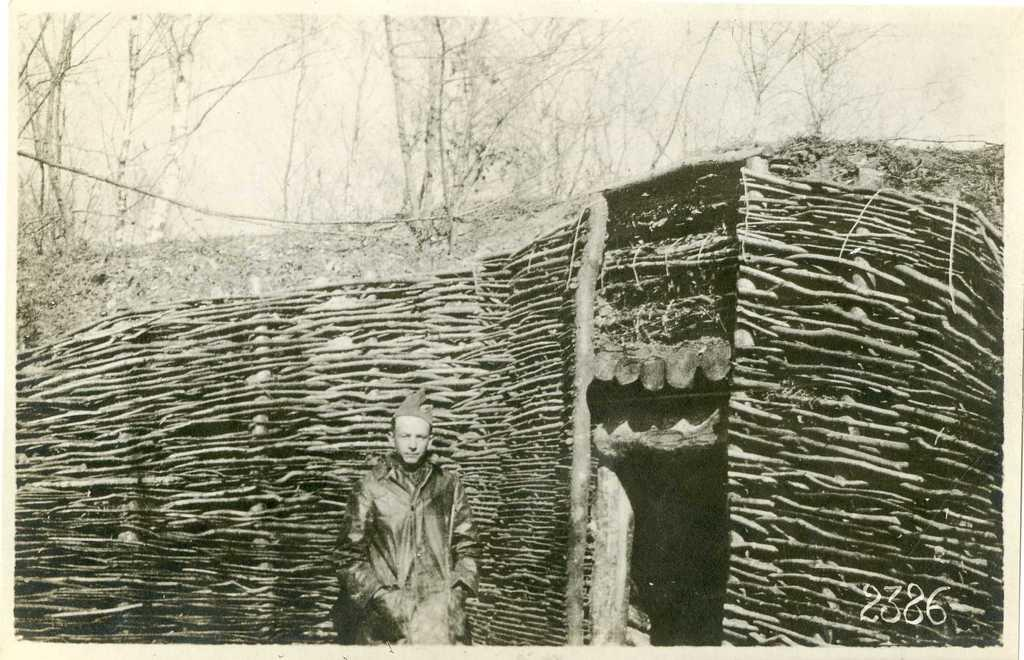What is the main subject of the image? There is a photo in the image. What is unique about the photo? The photo contains another photo. Can you describe the scene in the inner photo? There is a person standing in the inner photo. What is the person doing or standing near in the inner photo? The person is standing near sticks in the inner photo. What type of art supplies can be seen in the image? There are no art supplies visible in the image. 